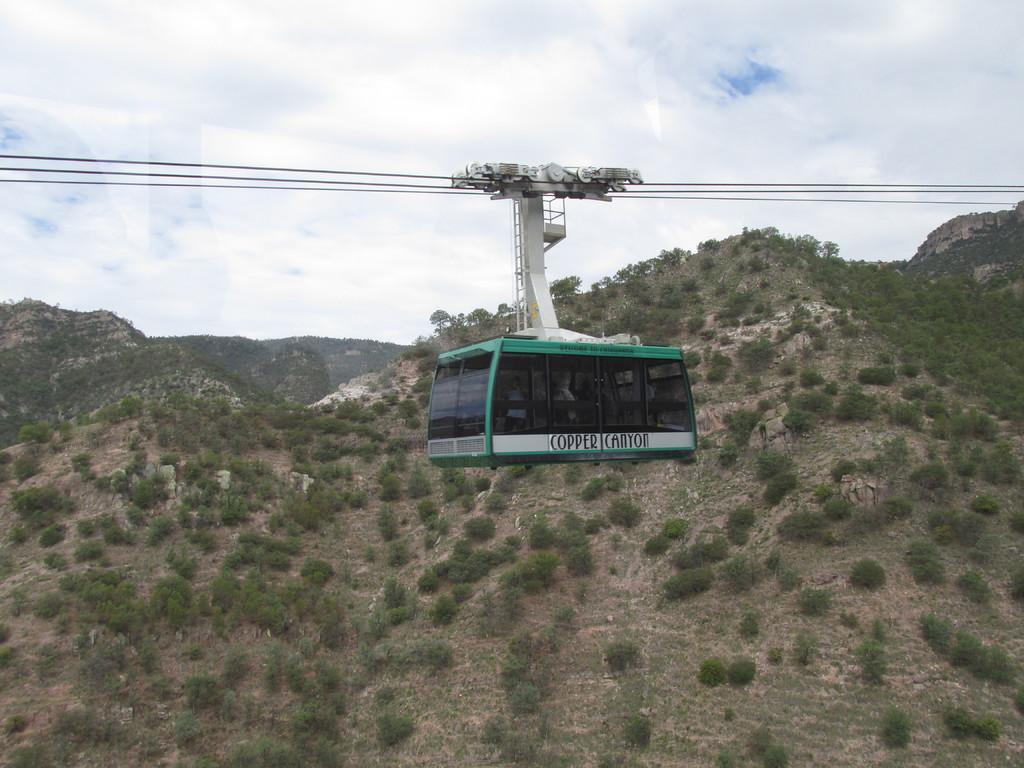Please provide a concise description of this image. In the image we can see ropeway, mountains, trees and the cloudy sky. 